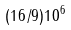<formula> <loc_0><loc_0><loc_500><loc_500>( 1 6 / 9 ) 1 0 ^ { 6 }</formula> 